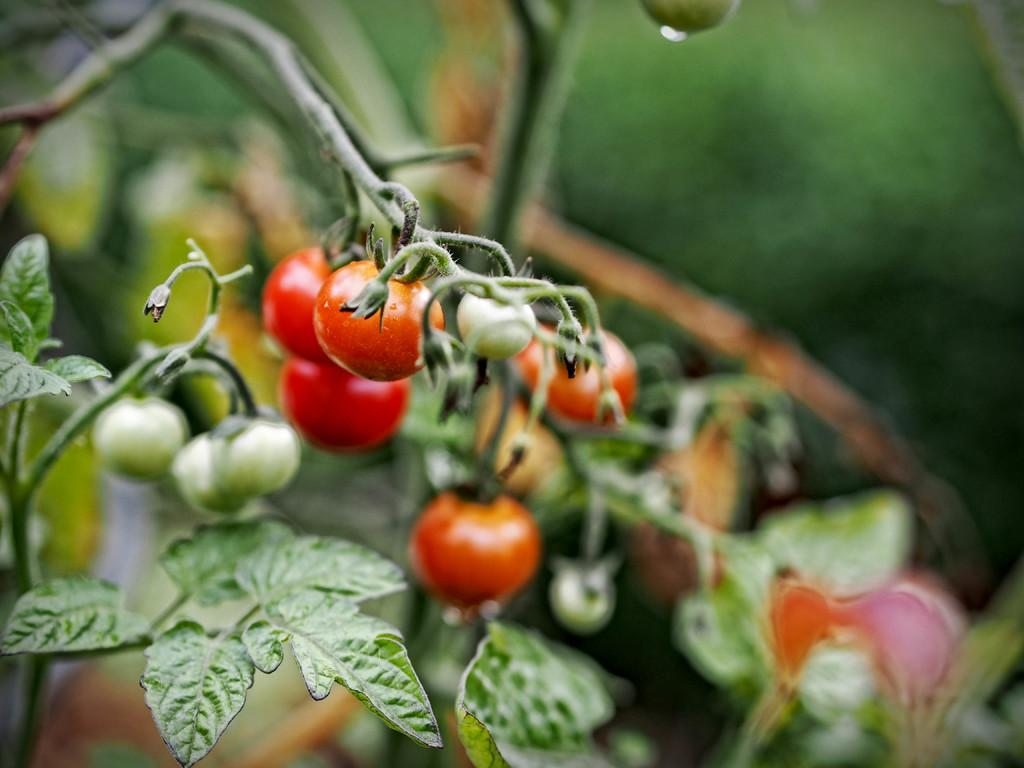What is the focus of the image? The image is zoomed in, so the focus is on a specific area. What can be seen in the foreground of the image? There are leaves and tomatoes hanging on a tree in the foreground. How would you describe the background of the image? The background of the image is blurry. What type of knee injury can be seen in the image? There is no knee injury present in the image; it features leaves and tomatoes hanging on a tree. How many nails are visible in the image? There are no nails visible in the image. 